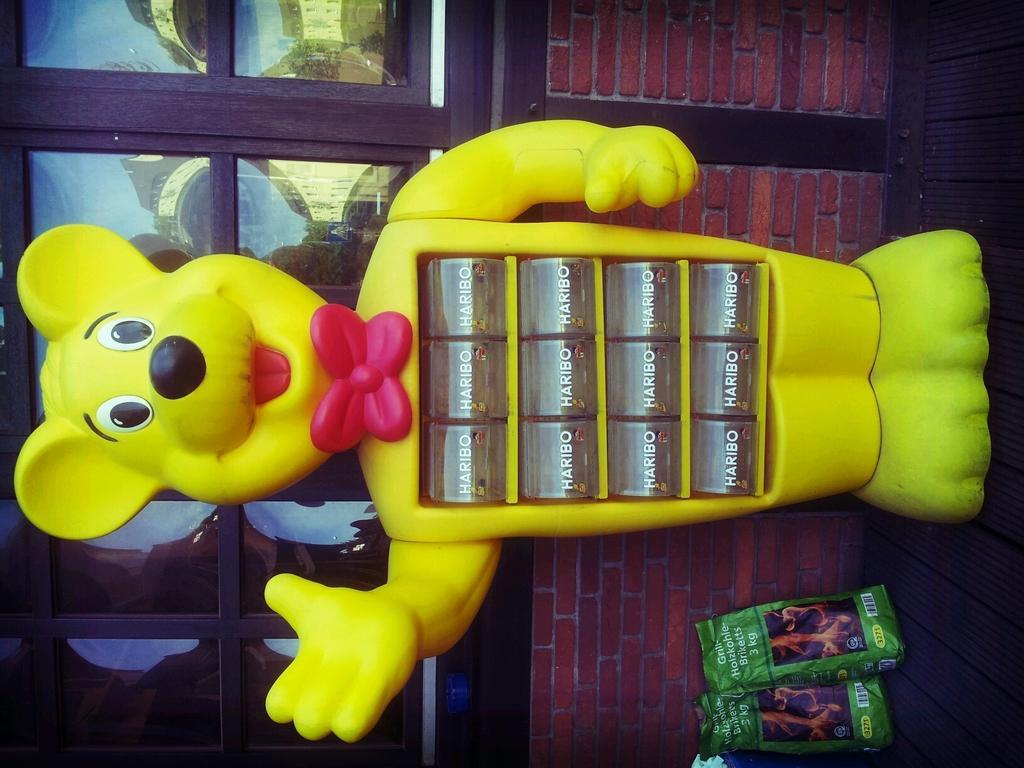Can you describe this image briefly? In this picture we can see a toy and packets on the floor and in the background we can see a wall and windows. 